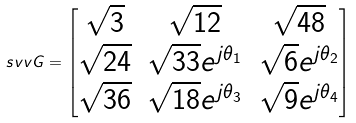<formula> <loc_0><loc_0><loc_500><loc_500>\ s v v { G } = \begin{bmatrix} \sqrt { 3 } & \sqrt { 1 2 } & \sqrt { 4 8 } \\ \sqrt { 2 4 } & \sqrt { 3 3 } e ^ { j \theta _ { 1 } } & \sqrt { 6 } e ^ { j \theta _ { 2 } } \\ \sqrt { 3 6 } & \sqrt { 1 8 } e ^ { j \theta _ { 3 } } & \sqrt { 9 } e ^ { j \theta _ { 4 } } \end{bmatrix}</formula> 